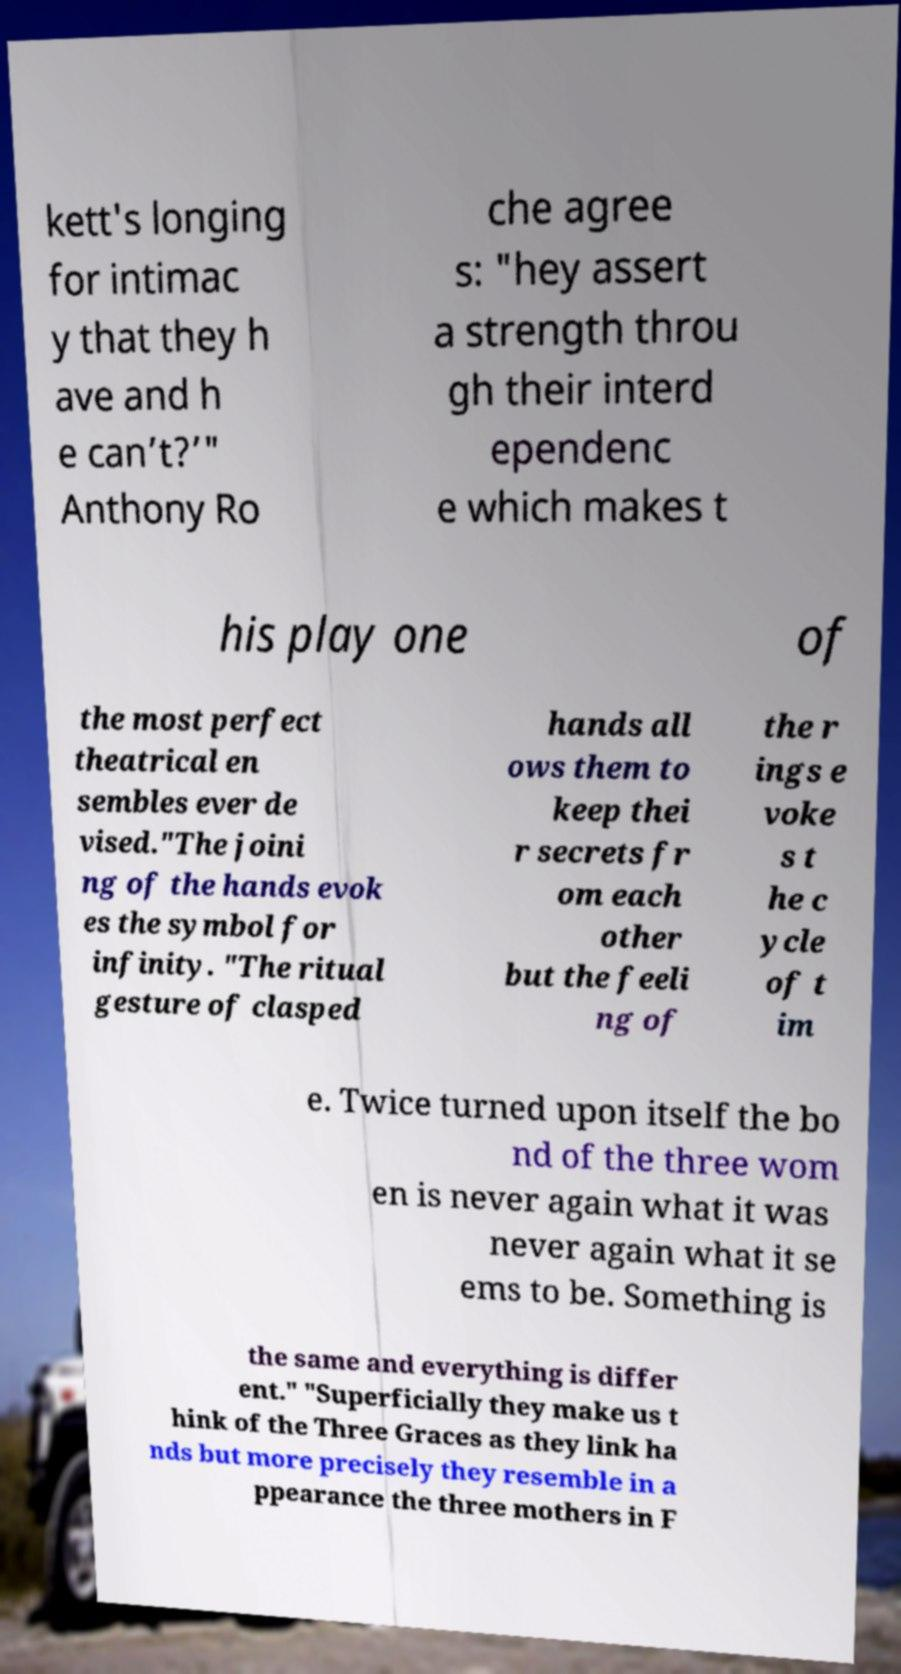I need the written content from this picture converted into text. Can you do that? kett's longing for intimac y that they h ave and h e can’t?’" Anthony Ro che agree s: "hey assert a strength throu gh their interd ependenc e which makes t his play one of the most perfect theatrical en sembles ever de vised."The joini ng of the hands evok es the symbol for infinity. "The ritual gesture of clasped hands all ows them to keep thei r secrets fr om each other but the feeli ng of the r ings e voke s t he c ycle of t im e. Twice turned upon itself the bo nd of the three wom en is never again what it was never again what it se ems to be. Something is the same and everything is differ ent." "Superficially they make us t hink of the Three Graces as they link ha nds but more precisely they resemble in a ppearance the three mothers in F 